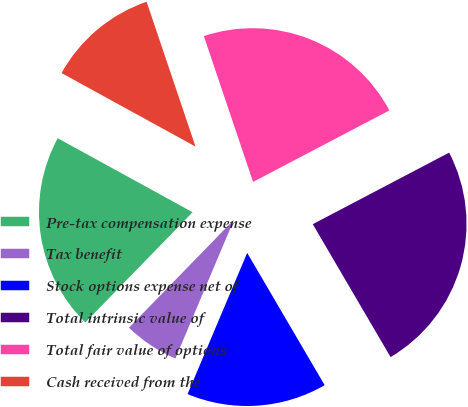Convert chart to OTSL. <chart><loc_0><loc_0><loc_500><loc_500><pie_chart><fcel>Pre-tax compensation expense<fcel>Tax benefit<fcel>Stock options expense net of<fcel>Total intrinsic value of<fcel>Total fair value of options<fcel>Cash received from the<nl><fcel>20.71%<fcel>5.92%<fcel>14.79%<fcel>24.26%<fcel>22.49%<fcel>11.83%<nl></chart> 